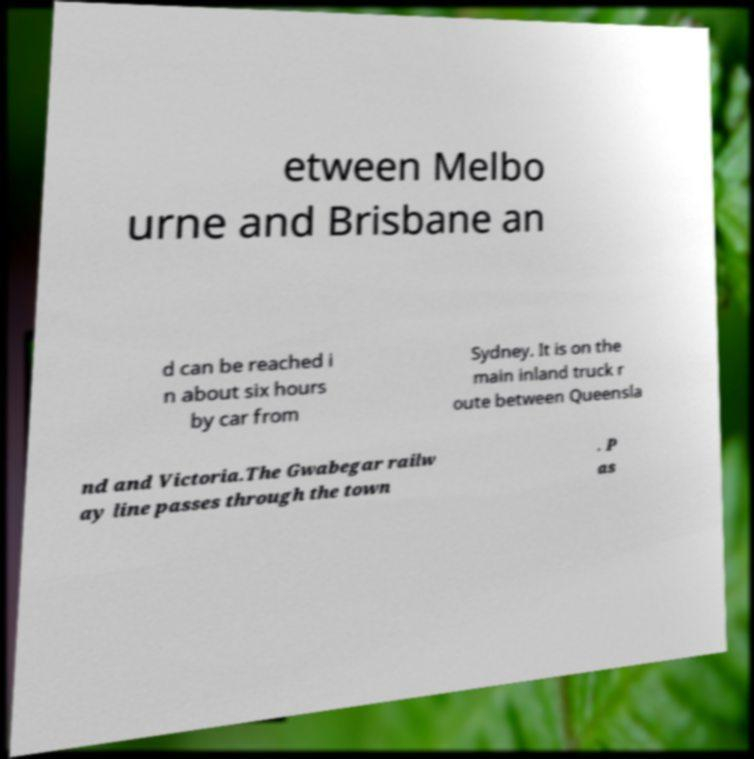Can you read and provide the text displayed in the image?This photo seems to have some interesting text. Can you extract and type it out for me? etween Melbo urne and Brisbane an d can be reached i n about six hours by car from Sydney. It is on the main inland truck r oute between Queensla nd and Victoria.The Gwabegar railw ay line passes through the town . P as 